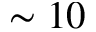Convert formula to latex. <formula><loc_0><loc_0><loc_500><loc_500>\sim 1 0</formula> 